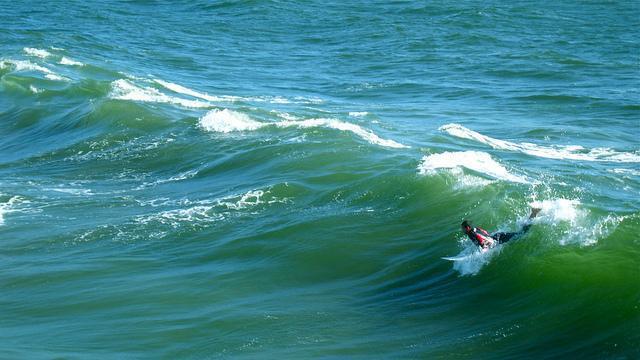How many surfers are there?
Give a very brief answer. 1. How many hot dogs are there?
Give a very brief answer. 0. 